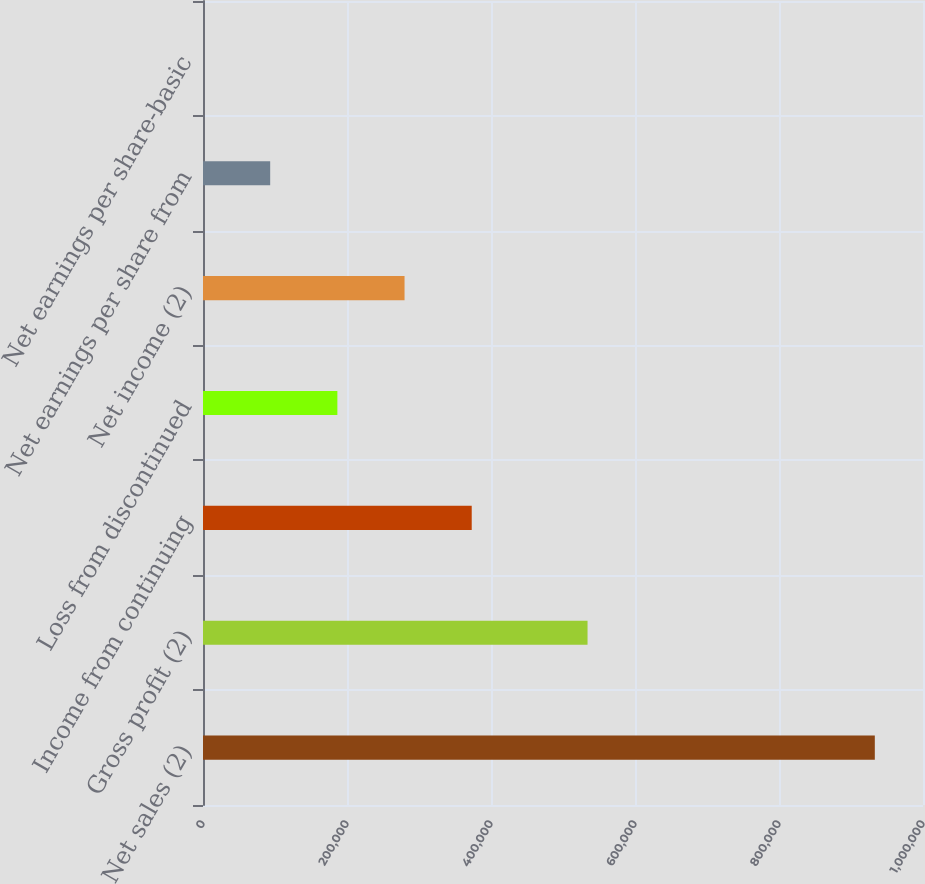Convert chart. <chart><loc_0><loc_0><loc_500><loc_500><bar_chart><fcel>Net sales (2)<fcel>Gross profit (2)<fcel>Income from continuing<fcel>Loss from discontinued<fcel>Net income (2)<fcel>Net earnings per share from<fcel>Net earnings per share-basic<nl><fcel>933070<fcel>534074<fcel>373230<fcel>186617<fcel>279923<fcel>93310.2<fcel>3.53<nl></chart> 